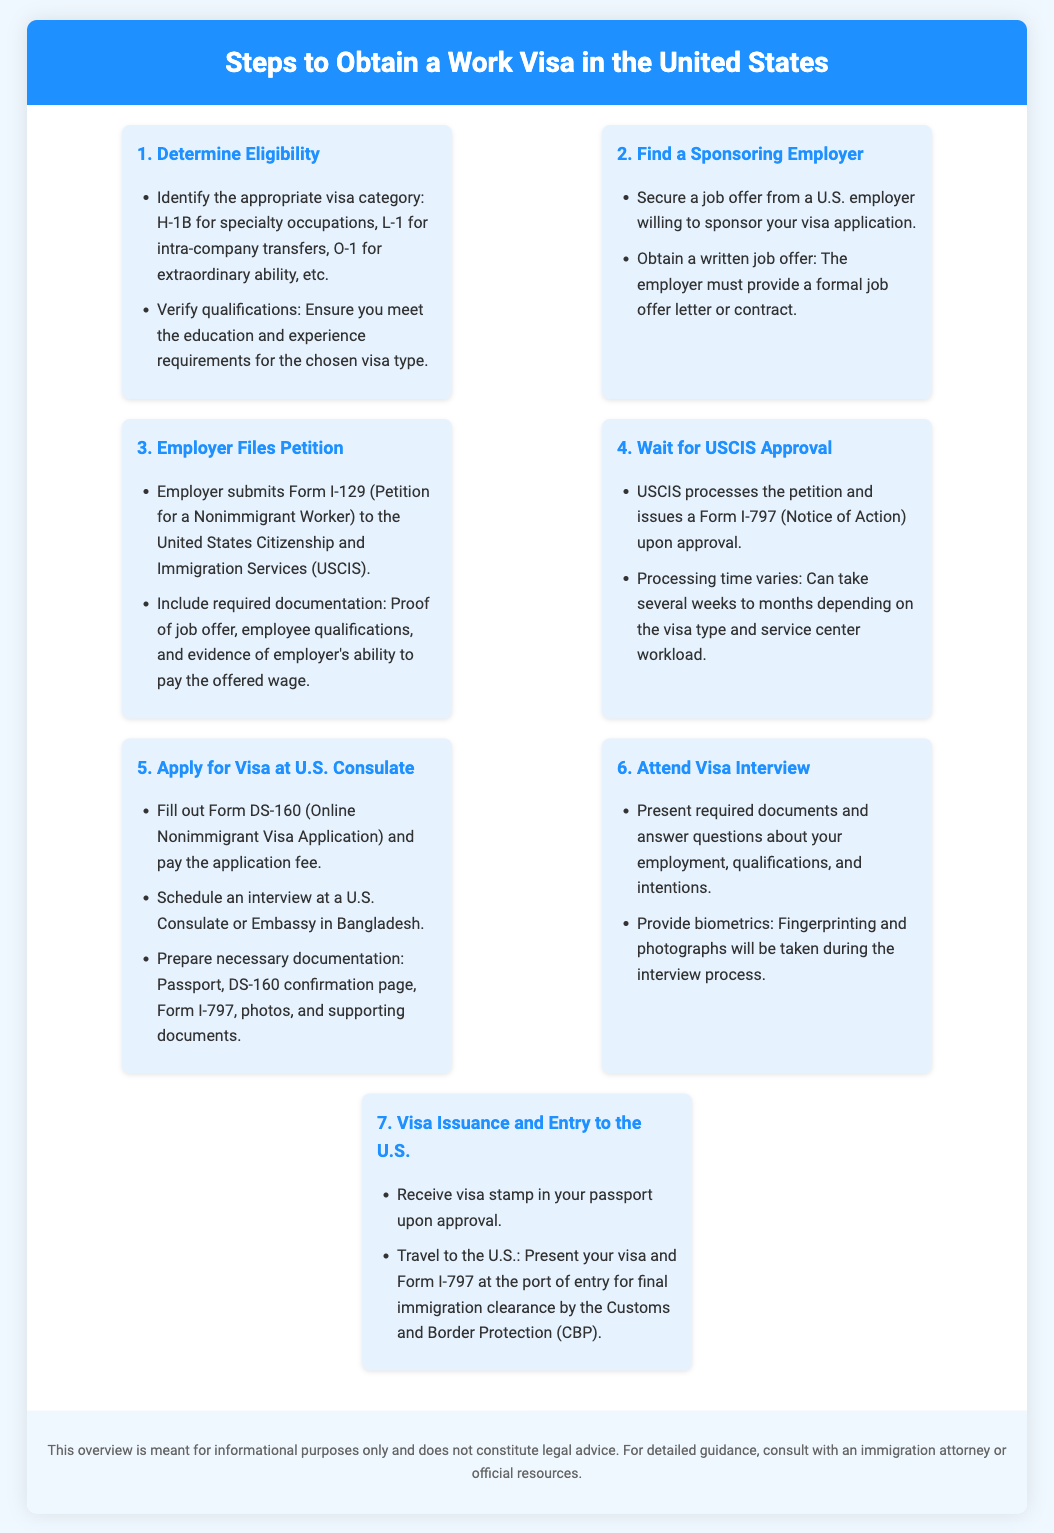What is the first step to obtain a work visa? The first step is to determine eligibility, which includes identifying the appropriate visa category and verifying qualifications.
Answer: Determine Eligibility What form does the employer submit? The employer submits Form I-129, which is the Petition for a Nonimmigrant Worker, to USCIS.
Answer: Form I-129 How many visa types are mentioned? Three specific visa types are mentioned: H-1B, L-1, and O-1.
Answer: Three What is required during the visa interview? Required actions during the visa interview include presenting necessary documents and providing biometrics like fingerprints and photographs.
Answer: Present documents and provide biometrics What document confirms the USCIS approval? The document that confirms USCIS approval is Form I-797, which is also known as the Notice of Action.
Answer: Form I-797 What is the last step in the visa process? The last step in the visa process is receiving the visa stamp in your passport and traveling to the U.S.
Answer: Visa Issuance and Entry to the U.S How long does USCIS processing take? USCIS processing time varies and can take several weeks to months depending on various factors.
Answer: Several weeks to months What must be included in the job offer? The job offer must include a formal job offer letter or contract from the employer.
Answer: Formal job offer letter or contract What is the form number for the nonimmigrant visa application? The form number for the online nonimmigrant visa application is DS-160.
Answer: DS-160 